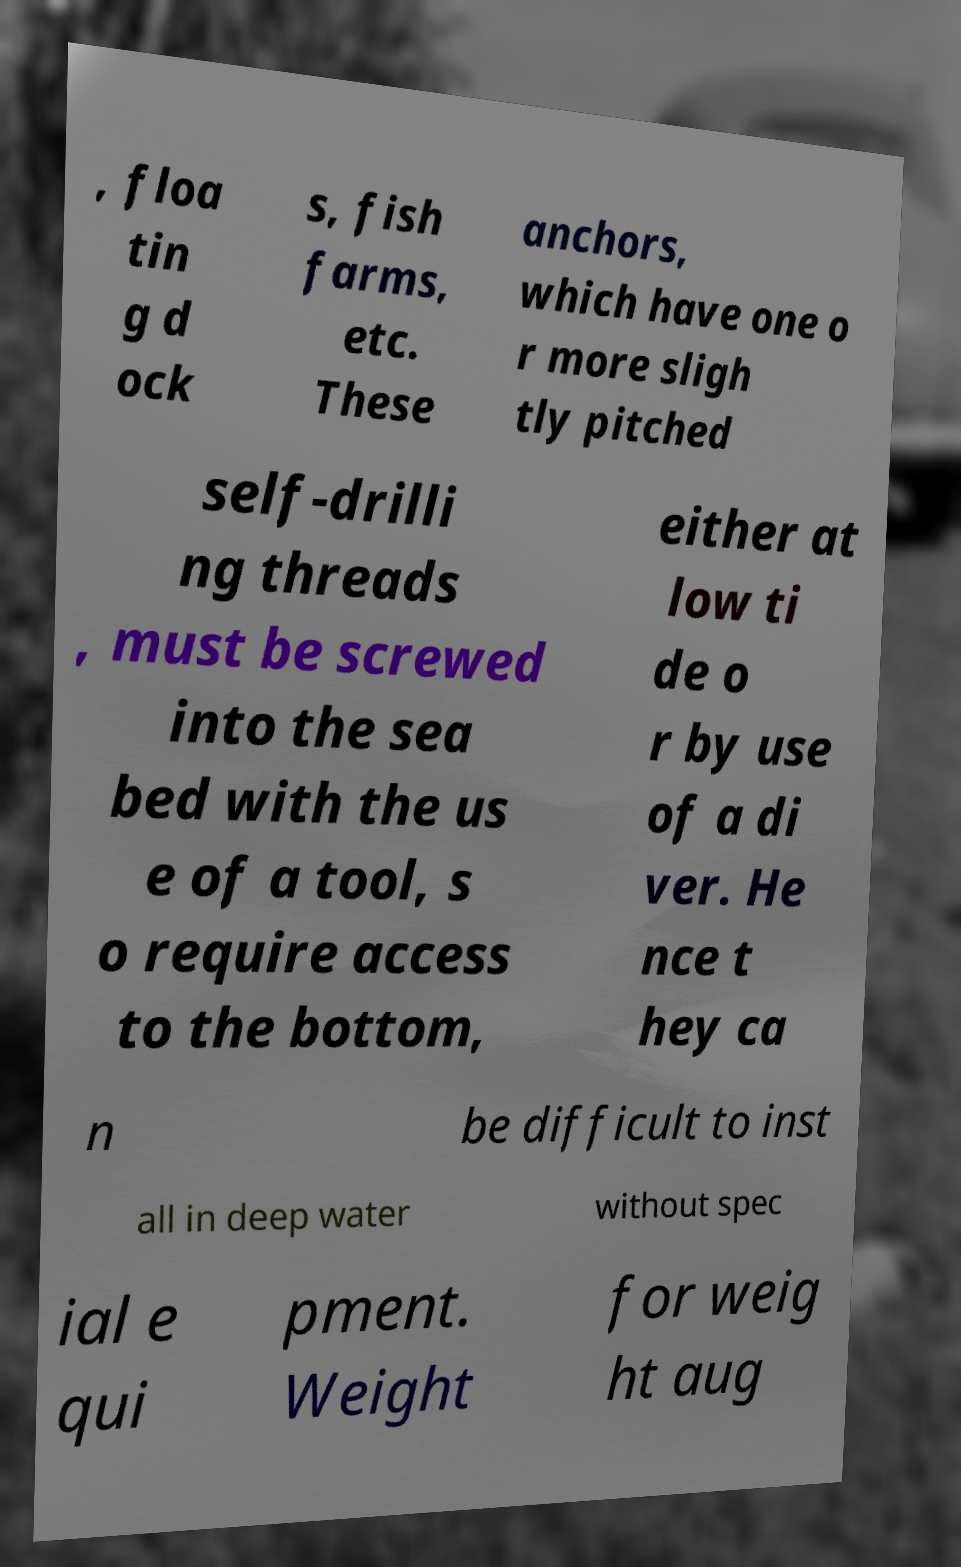Please identify and transcribe the text found in this image. , floa tin g d ock s, fish farms, etc. These anchors, which have one o r more sligh tly pitched self-drilli ng threads , must be screwed into the sea bed with the us e of a tool, s o require access to the bottom, either at low ti de o r by use of a di ver. He nce t hey ca n be difficult to inst all in deep water without spec ial e qui pment. Weight for weig ht aug 